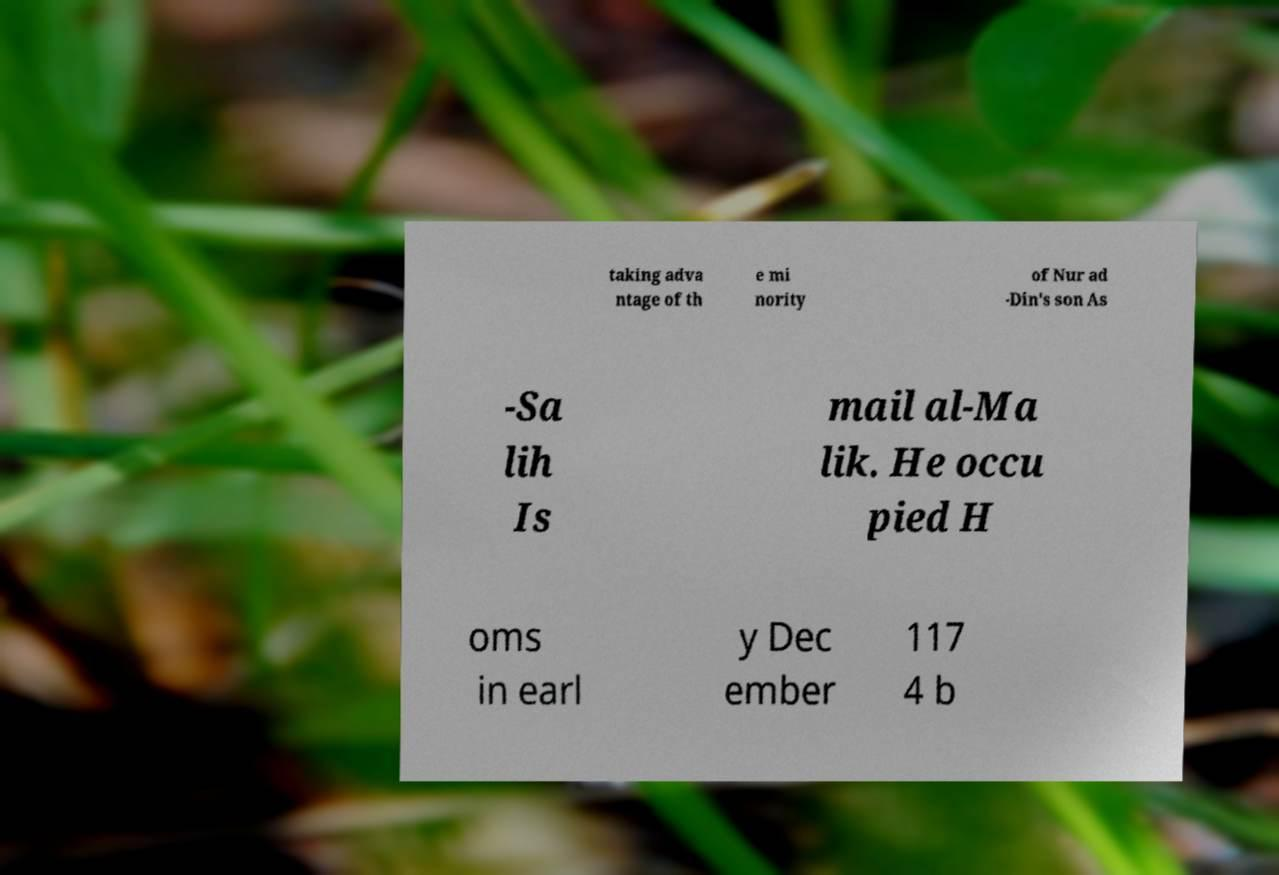Could you assist in decoding the text presented in this image and type it out clearly? taking adva ntage of th e mi nority of Nur ad -Din's son As -Sa lih Is mail al-Ma lik. He occu pied H oms in earl y Dec ember 117 4 b 